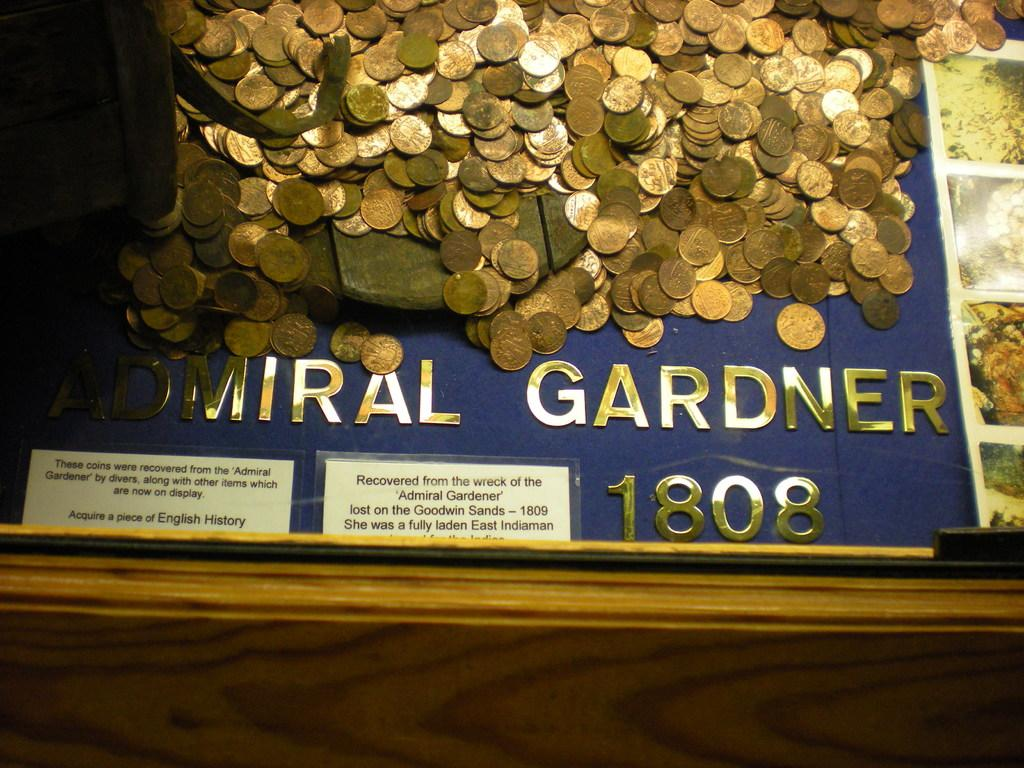<image>
Provide a brief description of the given image. A lot of coins are sitting on top of a plaque about Admiral Gardner. 